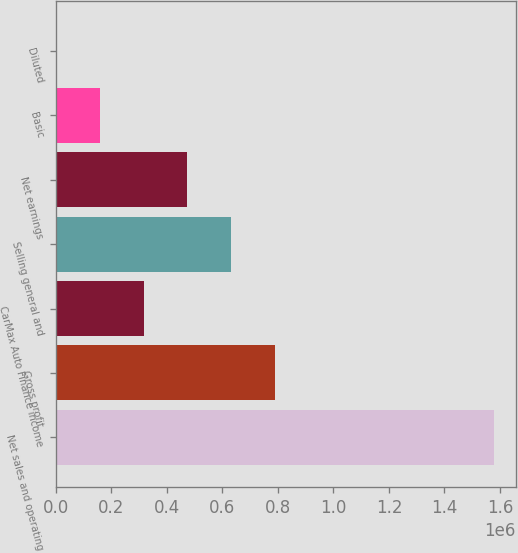Convert chart. <chart><loc_0><loc_0><loc_500><loc_500><bar_chart><fcel>Net sales and operating<fcel>Gross profit<fcel>CarMax Auto Finance income<fcel>Selling general and<fcel>Net earnings<fcel>Basic<fcel>Diluted<nl><fcel>1.57836e+06<fcel>789180<fcel>315672<fcel>631344<fcel>473508<fcel>157836<fcel>0.17<nl></chart> 